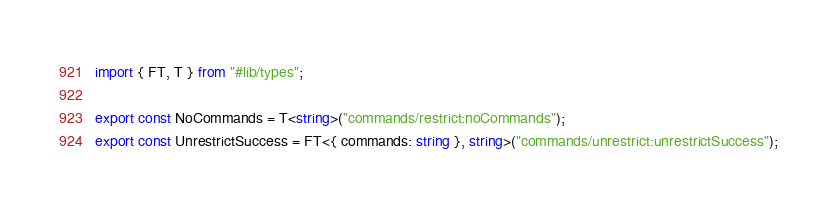Convert code to text. <code><loc_0><loc_0><loc_500><loc_500><_TypeScript_>import { FT, T } from "#lib/types";

export const NoCommands = T<string>("commands/restrict:noCommands");
export const UnrestrictSuccess = FT<{ commands: string }, string>("commands/unrestrict:unrestrictSuccess");
</code> 